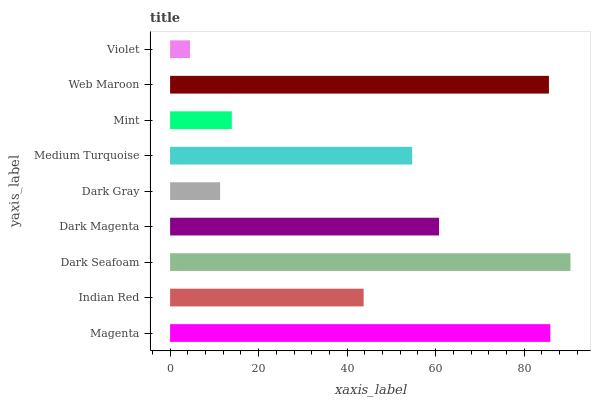Is Violet the minimum?
Answer yes or no. Yes. Is Dark Seafoam the maximum?
Answer yes or no. Yes. Is Indian Red the minimum?
Answer yes or no. No. Is Indian Red the maximum?
Answer yes or no. No. Is Magenta greater than Indian Red?
Answer yes or no. Yes. Is Indian Red less than Magenta?
Answer yes or no. Yes. Is Indian Red greater than Magenta?
Answer yes or no. No. Is Magenta less than Indian Red?
Answer yes or no. No. Is Medium Turquoise the high median?
Answer yes or no. Yes. Is Medium Turquoise the low median?
Answer yes or no. Yes. Is Web Maroon the high median?
Answer yes or no. No. Is Violet the low median?
Answer yes or no. No. 